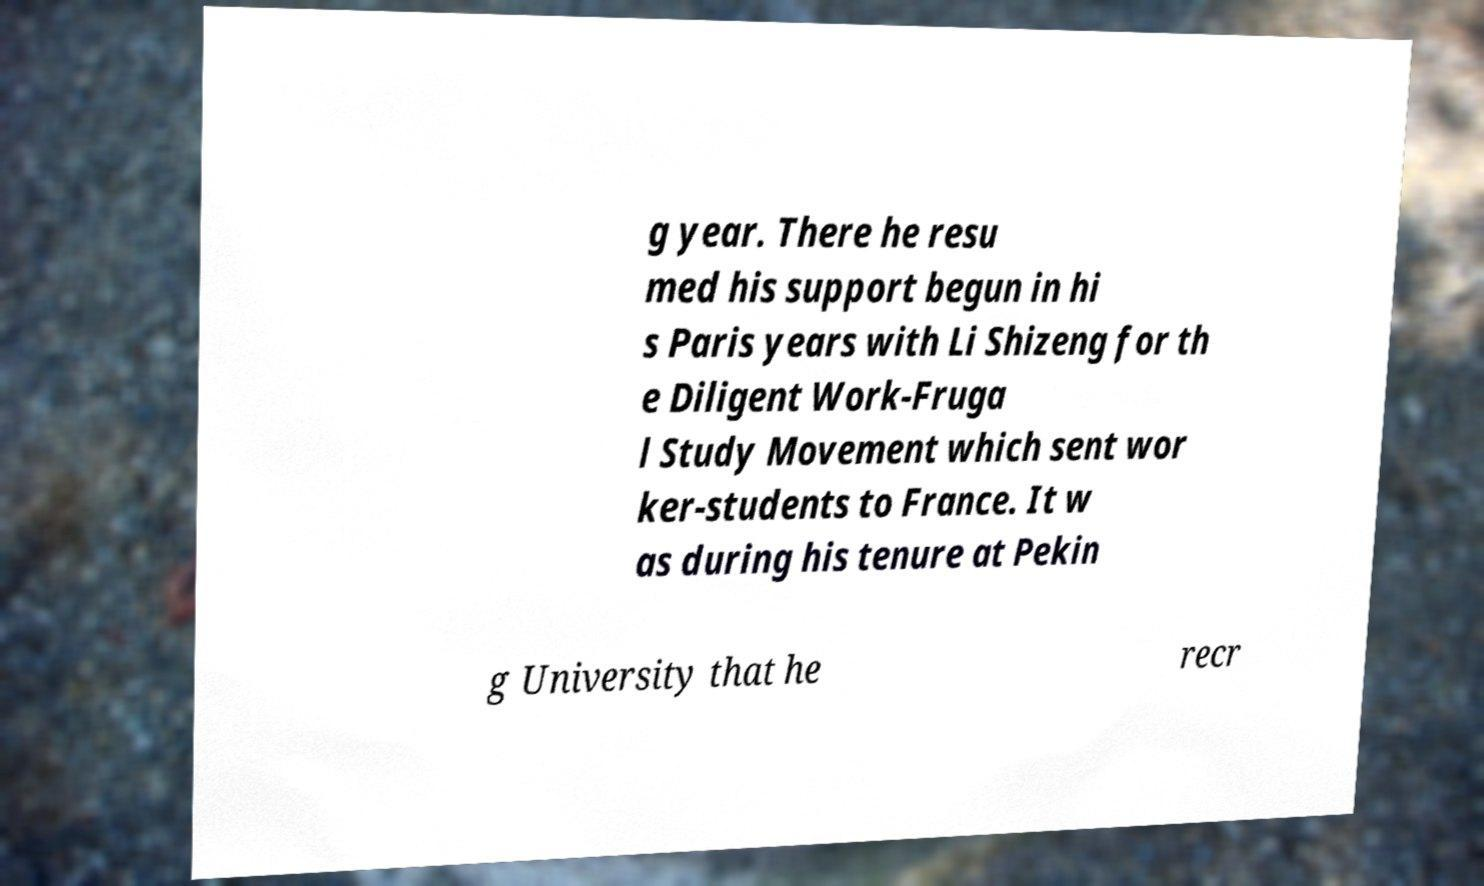Please read and relay the text visible in this image. What does it say? g year. There he resu med his support begun in hi s Paris years with Li Shizeng for th e Diligent Work-Fruga l Study Movement which sent wor ker-students to France. It w as during his tenure at Pekin g University that he recr 